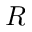<formula> <loc_0><loc_0><loc_500><loc_500>R</formula> 